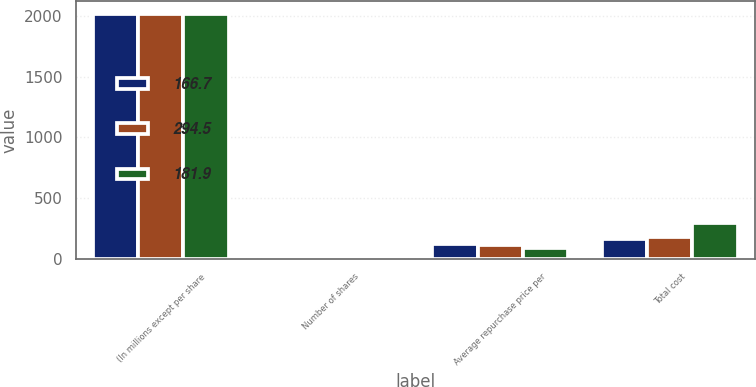Convert chart. <chart><loc_0><loc_0><loc_500><loc_500><stacked_bar_chart><ecel><fcel>(In millions except per share<fcel>Number of shares<fcel>Average repurchase price per<fcel>Total cost<nl><fcel>166.7<fcel>2019<fcel>1.4<fcel>121.76<fcel>166.7<nl><fcel>294.5<fcel>2018<fcel>1.6<fcel>112.63<fcel>181.9<nl><fcel>181.9<fcel>2017<fcel>3.3<fcel>90.63<fcel>294.5<nl></chart> 